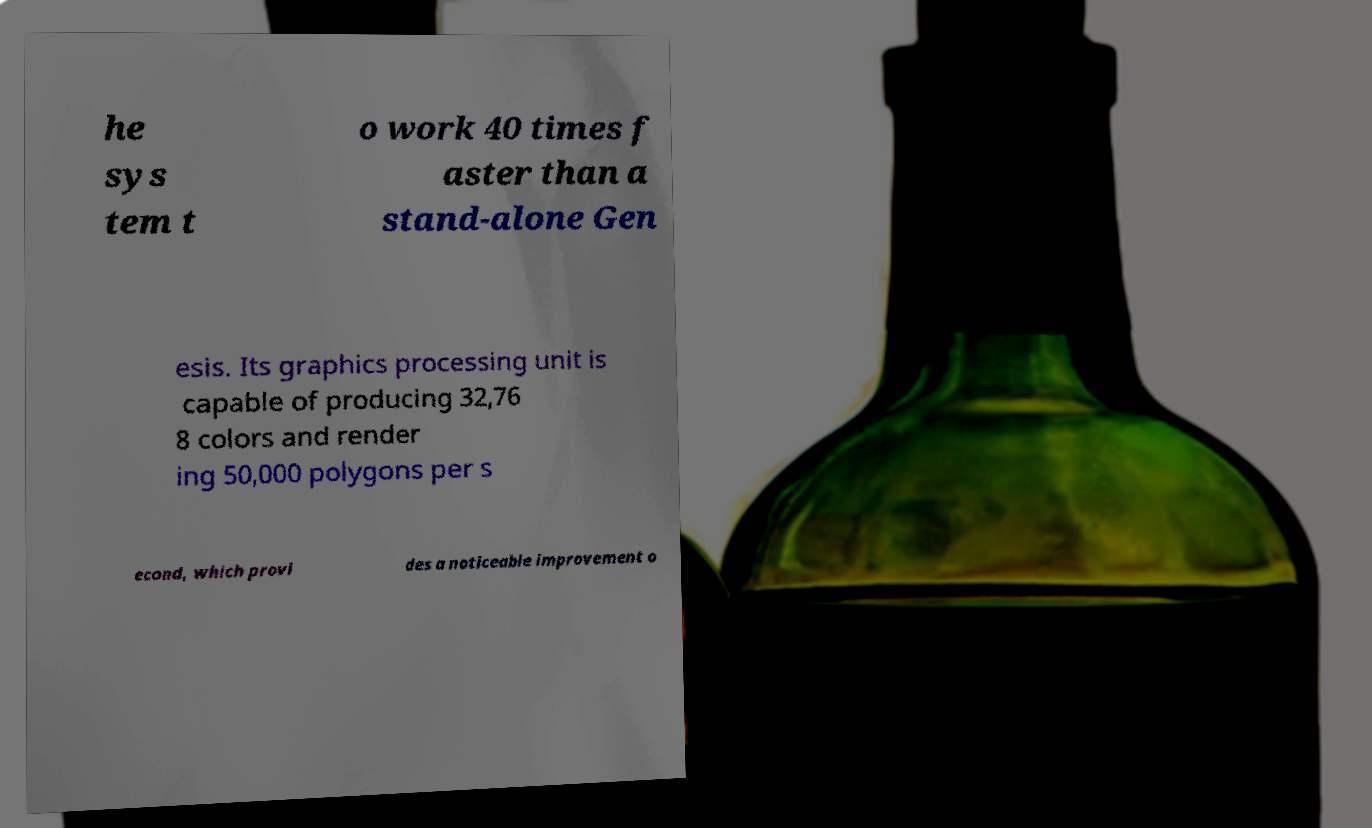Please read and relay the text visible in this image. What does it say? he sys tem t o work 40 times f aster than a stand-alone Gen esis. Its graphics processing unit is capable of producing 32,76 8 colors and render ing 50,000 polygons per s econd, which provi des a noticeable improvement o 